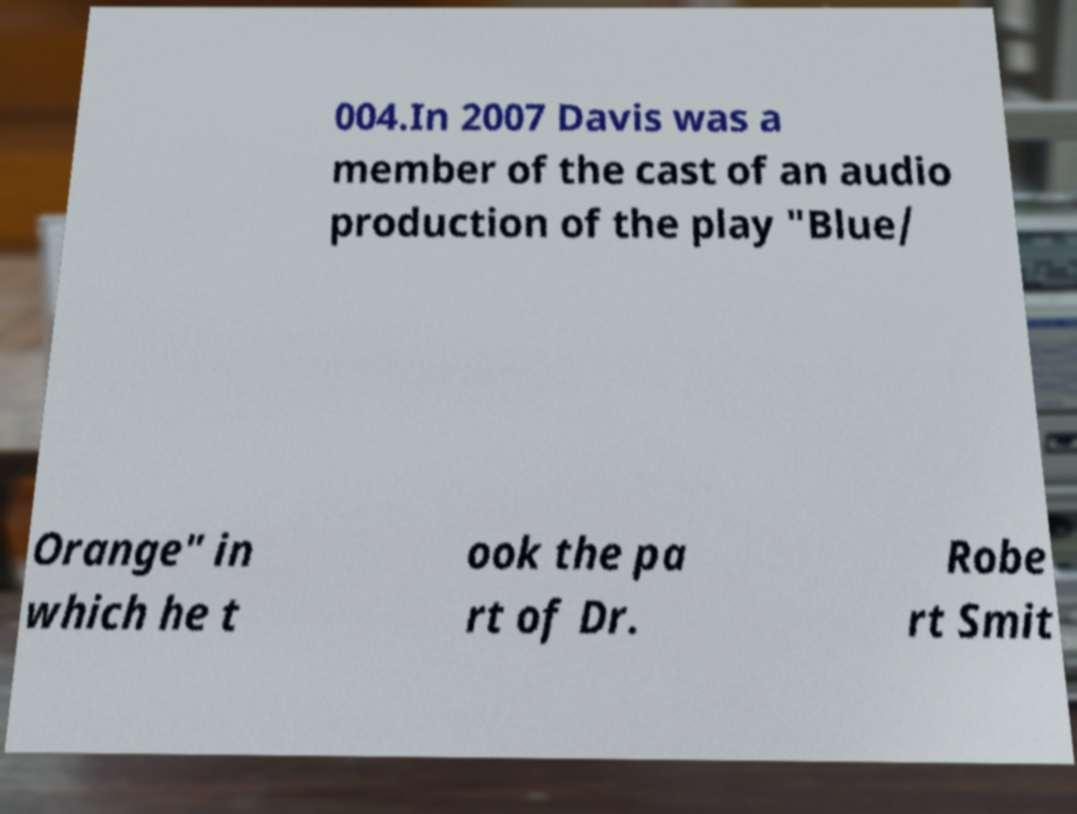For documentation purposes, I need the text within this image transcribed. Could you provide that? 004.In 2007 Davis was a member of the cast of an audio production of the play "Blue/ Orange" in which he t ook the pa rt of Dr. Robe rt Smit 